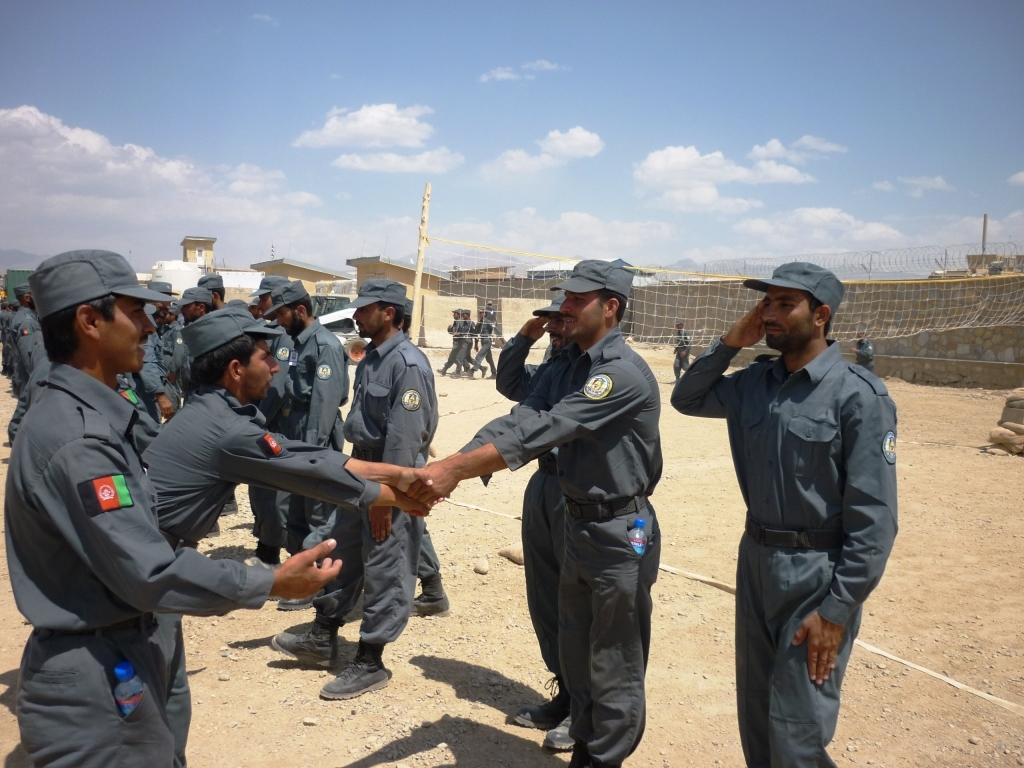What can be seen in the image? There is a group of people in the image. What are the people wearing? The people are wearing grey dresses and caps. What is on the right side of the image? There is a net on the right side of the image. How would you describe the weather in the image? The sky is sunny in the image. What type of jar is being used for teaching in the image? There is no jar or teaching activity present in the image. 